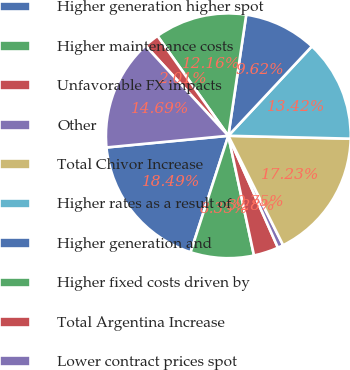Convert chart to OTSL. <chart><loc_0><loc_0><loc_500><loc_500><pie_chart><fcel>Higher generation higher spot<fcel>Higher maintenance costs<fcel>Unfavorable FX impacts<fcel>Other<fcel>Total Chivor Increase<fcel>Higher rates as a result of<fcel>Higher generation and<fcel>Higher fixed costs driven by<fcel>Total Argentina Increase<fcel>Lower contract prices spot<nl><fcel>18.49%<fcel>8.35%<fcel>3.28%<fcel>0.75%<fcel>17.23%<fcel>13.42%<fcel>9.62%<fcel>12.16%<fcel>2.01%<fcel>14.69%<nl></chart> 